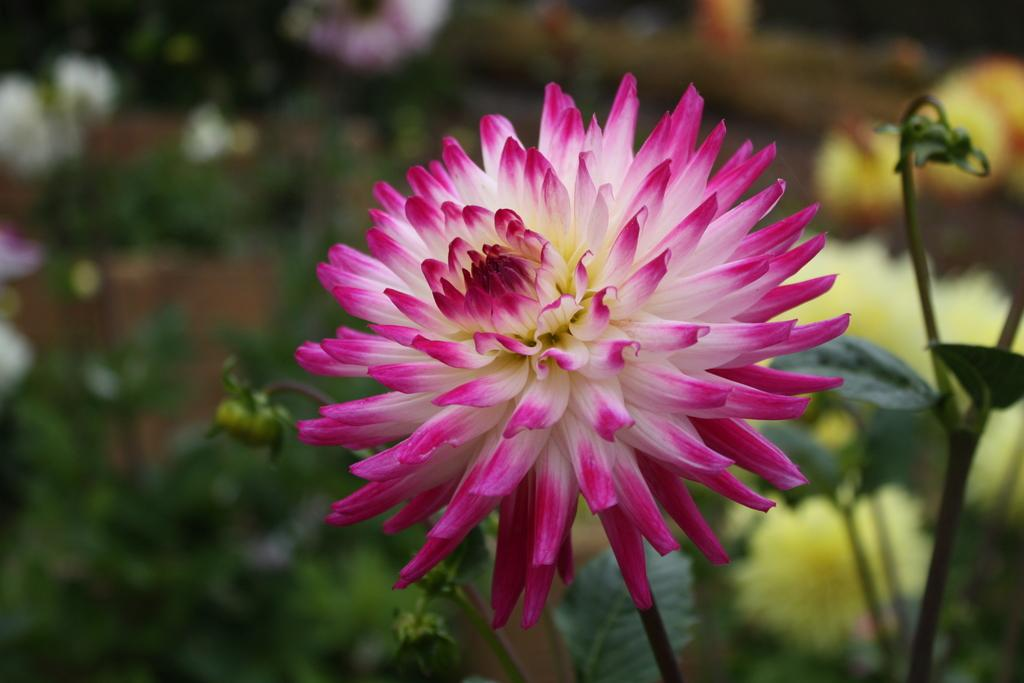What is the main subject of the image? There is a flower in the image. Can you describe the colors of the flower? The flower has white and pink colors. What can be seen in the background of the image? The background of the image contains plants. What are the characteristics of the plants in the background? The plants have flowers, buds, and leaves. How many cats are sitting on the jar in the image? There are no cats or jars present in the image. What type of eggs can be seen in the image? There are no eggs present in the image. 